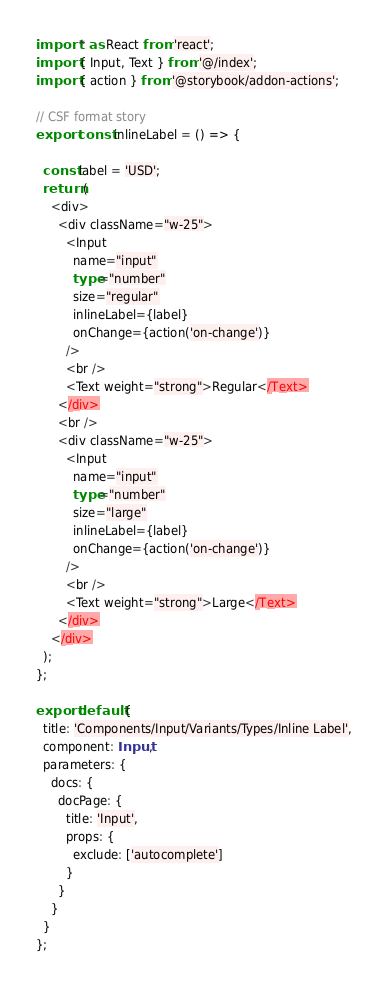<code> <loc_0><loc_0><loc_500><loc_500><_TypeScript_>import * as React from 'react';
import { Input, Text } from '@/index';
import { action } from '@storybook/addon-actions';

// CSF format story
export const inlineLabel = () => {

  const label = 'USD';
  return (
    <div>
      <div className="w-25">
        <Input
          name="input"
          type="number"
          size="regular"
          inlineLabel={label}
          onChange={action('on-change')}
        />
        <br />
        <Text weight="strong">Regular</Text>
      </div>
      <br />
      <div className="w-25">
        <Input
          name="input"
          type="number"
          size="large"
          inlineLabel={label}
          onChange={action('on-change')}
        />
        <br />
        <Text weight="strong">Large</Text>
      </div>
    </div>
  );
};

export default {
  title: 'Components/Input/Variants/Types/Inline Label',
  component: Input,
  parameters: {
    docs: {
      docPage: {
        title: 'Input',
        props: {
          exclude: ['autocomplete']
        }
      }
    }
  }
};
</code> 